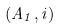Convert formula to latex. <formula><loc_0><loc_0><loc_500><loc_500>( A _ { 1 } , i )</formula> 